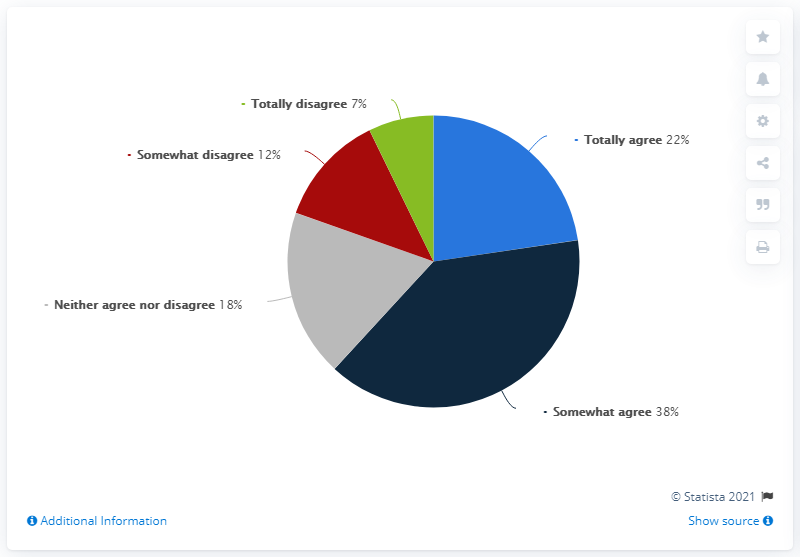What insights can we draw from the distribution of responses? The distribution suggests a leaning towards agreement with the statement, as the combined 'somewhat agree' and 'totally agree' categories account for 60% of responses, while the disagreement portion totals only 19%. This indicates a majority favor the view or sentiment being measured. However, the 18% of 'neither agree nor disagree' responses indicate a significant portion of neutrality or indecision among participants. This pattern may inform strategies to address the concerns of the undecided respondents or to reinforce the positive perception among those who agree. 